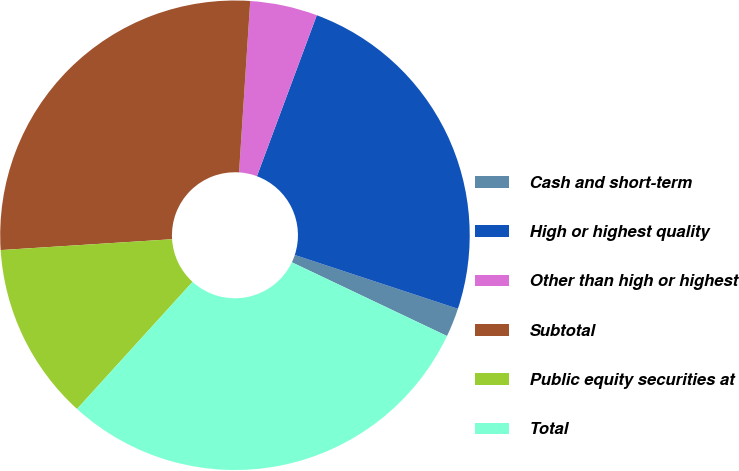Convert chart. <chart><loc_0><loc_0><loc_500><loc_500><pie_chart><fcel>Cash and short-term<fcel>High or highest quality<fcel>Other than high or highest<fcel>Subtotal<fcel>Public equity securities at<fcel>Total<nl><fcel>1.99%<fcel>24.4%<fcel>4.63%<fcel>27.04%<fcel>12.25%<fcel>29.68%<nl></chart> 